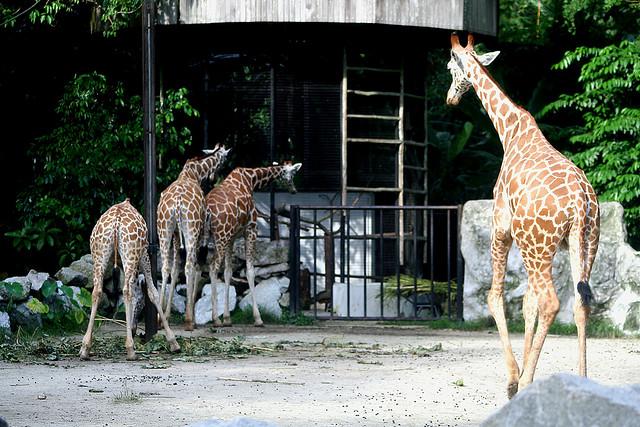Are these giraffes living free range?
Keep it brief. No. Is the giraffe eating the leaves?
Quick response, please. No. How many giraffes are there?
Give a very brief answer. 4. 